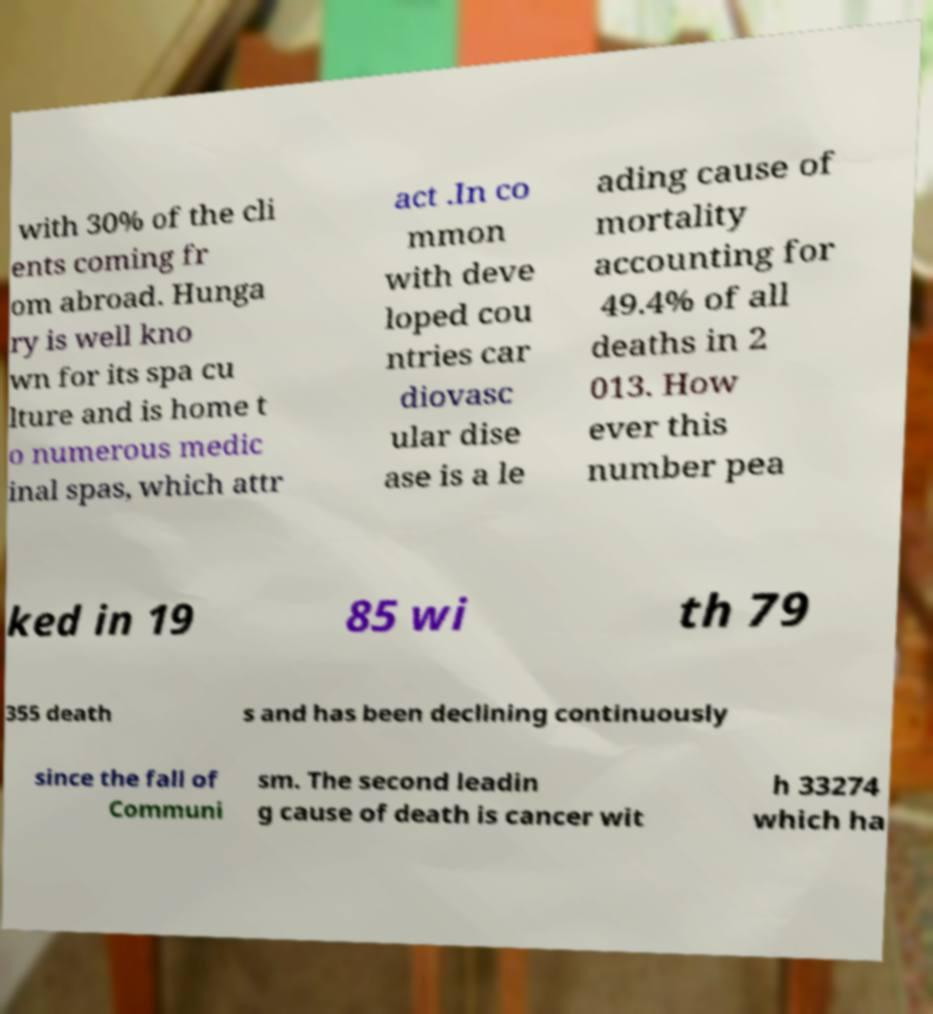Can you read and provide the text displayed in the image?This photo seems to have some interesting text. Can you extract and type it out for me? with 30% of the cli ents coming fr om abroad. Hunga ry is well kno wn for its spa cu lture and is home t o numerous medic inal spas, which attr act .In co mmon with deve loped cou ntries car diovasc ular dise ase is a le ading cause of mortality accounting for 49.4% of all deaths in 2 013. How ever this number pea ked in 19 85 wi th 79 355 death s and has been declining continuously since the fall of Communi sm. The second leadin g cause of death is cancer wit h 33274 which ha 